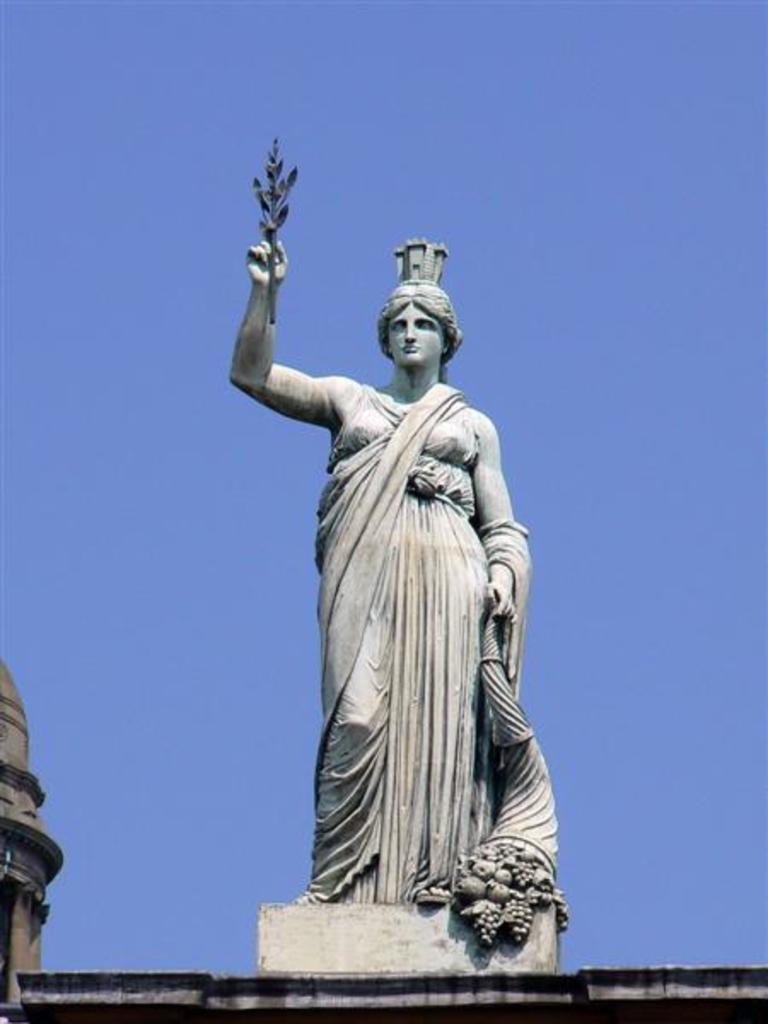Can you describe this image briefly? In this image I can see the statue of the person on the building. In the background I can see the sky. 